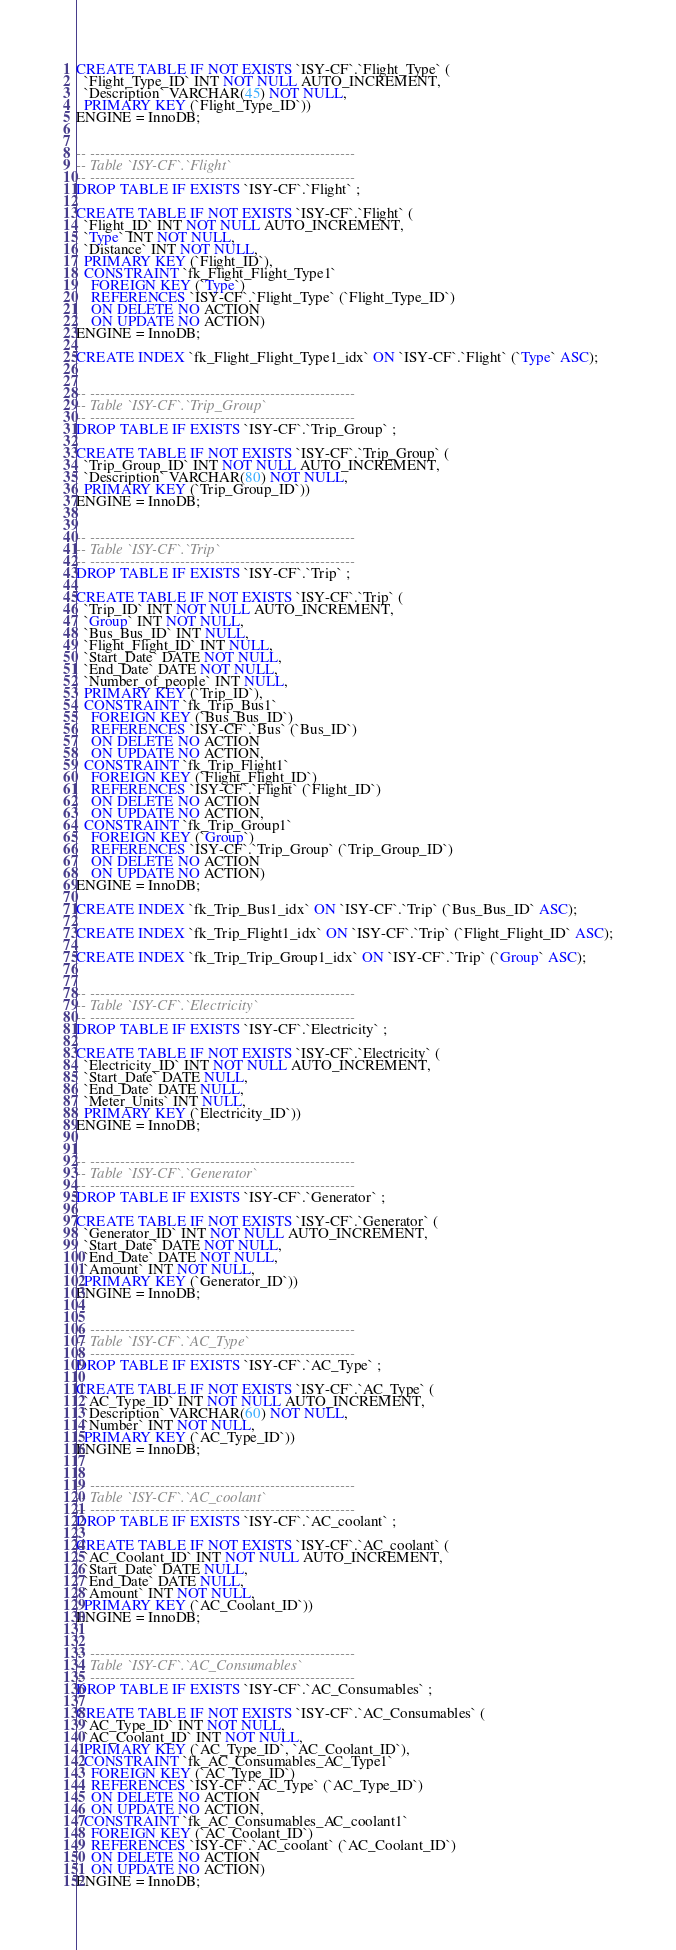Convert code to text. <code><loc_0><loc_0><loc_500><loc_500><_SQL_>
CREATE TABLE IF NOT EXISTS `ISY-CF`.`Flight_Type` (
  `Flight_Type_ID` INT NOT NULL AUTO_INCREMENT,
  `Description` VARCHAR(45) NOT NULL,
  PRIMARY KEY (`Flight_Type_ID`))
ENGINE = InnoDB;


-- -----------------------------------------------------
-- Table `ISY-CF`.`Flight`
-- -----------------------------------------------------
DROP TABLE IF EXISTS `ISY-CF`.`Flight` ;

CREATE TABLE IF NOT EXISTS `ISY-CF`.`Flight` (
  `Flight_ID` INT NOT NULL AUTO_INCREMENT,
  `Type` INT NOT NULL,
  `Distance` INT NOT NULL,
  PRIMARY KEY (`Flight_ID`),
  CONSTRAINT `fk_Flight_Flight_Type1`
    FOREIGN KEY (`Type`)
    REFERENCES `ISY-CF`.`Flight_Type` (`Flight_Type_ID`)
    ON DELETE NO ACTION
    ON UPDATE NO ACTION)
ENGINE = InnoDB;

CREATE INDEX `fk_Flight_Flight_Type1_idx` ON `ISY-CF`.`Flight` (`Type` ASC);


-- -----------------------------------------------------
-- Table `ISY-CF`.`Trip_Group`
-- -----------------------------------------------------
DROP TABLE IF EXISTS `ISY-CF`.`Trip_Group` ;

CREATE TABLE IF NOT EXISTS `ISY-CF`.`Trip_Group` (
  `Trip_Group_ID` INT NOT NULL AUTO_INCREMENT,
  `Description` VARCHAR(80) NOT NULL,
  PRIMARY KEY (`Trip_Group_ID`))
ENGINE = InnoDB;


-- -----------------------------------------------------
-- Table `ISY-CF`.`Trip`
-- -----------------------------------------------------
DROP TABLE IF EXISTS `ISY-CF`.`Trip` ;

CREATE TABLE IF NOT EXISTS `ISY-CF`.`Trip` (
  `Trip_ID` INT NOT NULL AUTO_INCREMENT,
  `Group` INT NOT NULL,
  `Bus_Bus_ID` INT NULL,
  `Flight_Flight_ID` INT NULL,
  `Start_Date` DATE NOT NULL,
  `End_Date` DATE NOT NULL,
  `Number_of_people` INT NULL,
  PRIMARY KEY (`Trip_ID`),
  CONSTRAINT `fk_Trip_Bus1`
    FOREIGN KEY (`Bus_Bus_ID`)
    REFERENCES `ISY-CF`.`Bus` (`Bus_ID`)
    ON DELETE NO ACTION
    ON UPDATE NO ACTION,
  CONSTRAINT `fk_Trip_Flight1`
    FOREIGN KEY (`Flight_Flight_ID`)
    REFERENCES `ISY-CF`.`Flight` (`Flight_ID`)
    ON DELETE NO ACTION
    ON UPDATE NO ACTION,
  CONSTRAINT `fk_Trip_Group1`
    FOREIGN KEY (`Group`)
    REFERENCES `ISY-CF`.`Trip_Group` (`Trip_Group_ID`)
    ON DELETE NO ACTION
    ON UPDATE NO ACTION)
ENGINE = InnoDB;

CREATE INDEX `fk_Trip_Bus1_idx` ON `ISY-CF`.`Trip` (`Bus_Bus_ID` ASC);

CREATE INDEX `fk_Trip_Flight1_idx` ON `ISY-CF`.`Trip` (`Flight_Flight_ID` ASC);

CREATE INDEX `fk_Trip_Trip_Group1_idx` ON `ISY-CF`.`Trip` (`Group` ASC);


-- -----------------------------------------------------
-- Table `ISY-CF`.`Electricity`
-- -----------------------------------------------------
DROP TABLE IF EXISTS `ISY-CF`.`Electricity` ;

CREATE TABLE IF NOT EXISTS `ISY-CF`.`Electricity` (
  `Electricity_ID` INT NOT NULL AUTO_INCREMENT,
  `Start_Date` DATE NULL,
  `End_Date` DATE NULL,
  `Meter_Units` INT NULL,
  PRIMARY KEY (`Electricity_ID`))
ENGINE = InnoDB;


-- -----------------------------------------------------
-- Table `ISY-CF`.`Generator`
-- -----------------------------------------------------
DROP TABLE IF EXISTS `ISY-CF`.`Generator` ;

CREATE TABLE IF NOT EXISTS `ISY-CF`.`Generator` (
  `Generator_ID` INT NOT NULL AUTO_INCREMENT,
  `Start_Date` DATE NOT NULL,
  `End_Date` DATE NOT NULL,
  `Amount` INT NOT NULL,
  PRIMARY KEY (`Generator_ID`))
ENGINE = InnoDB;


-- -----------------------------------------------------
-- Table `ISY-CF`.`AC_Type`
-- -----------------------------------------------------
DROP TABLE IF EXISTS `ISY-CF`.`AC_Type` ;

CREATE TABLE IF NOT EXISTS `ISY-CF`.`AC_Type` (
  `AC_Type_ID` INT NOT NULL AUTO_INCREMENT,
  `Description` VARCHAR(60) NOT NULL,
  `Number` INT NOT NULL,
  PRIMARY KEY (`AC_Type_ID`))
ENGINE = InnoDB;


-- -----------------------------------------------------
-- Table `ISY-CF`.`AC_coolant`
-- -----------------------------------------------------
DROP TABLE IF EXISTS `ISY-CF`.`AC_coolant` ;

CREATE TABLE IF NOT EXISTS `ISY-CF`.`AC_coolant` (
  `AC_Coolant_ID` INT NOT NULL AUTO_INCREMENT,
  `Start_Date` DATE NULL,
  `End_Date` DATE NULL,
  `Amount` INT NOT NULL,
  PRIMARY KEY (`AC_Coolant_ID`))
ENGINE = InnoDB;


-- -----------------------------------------------------
-- Table `ISY-CF`.`AC_Consumables`
-- -----------------------------------------------------
DROP TABLE IF EXISTS `ISY-CF`.`AC_Consumables` ;

CREATE TABLE IF NOT EXISTS `ISY-CF`.`AC_Consumables` (
  `AC_Type_ID` INT NOT NULL,
  `AC_Coolant_ID` INT NOT NULL,
  PRIMARY KEY (`AC_Type_ID`, `AC_Coolant_ID`),
  CONSTRAINT `fk_AC_Consumables_AC_Type1`
    FOREIGN KEY (`AC_Type_ID`)
    REFERENCES `ISY-CF`.`AC_Type` (`AC_Type_ID`)
    ON DELETE NO ACTION
    ON UPDATE NO ACTION,
  CONSTRAINT `fk_AC_Consumables_AC_coolant1`
    FOREIGN KEY (`AC_Coolant_ID`)
    REFERENCES `ISY-CF`.`AC_coolant` (`AC_Coolant_ID`)
    ON DELETE NO ACTION
    ON UPDATE NO ACTION)
ENGINE = InnoDB;
</code> 